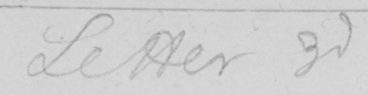What text is written in this handwritten line? Letter 3d 